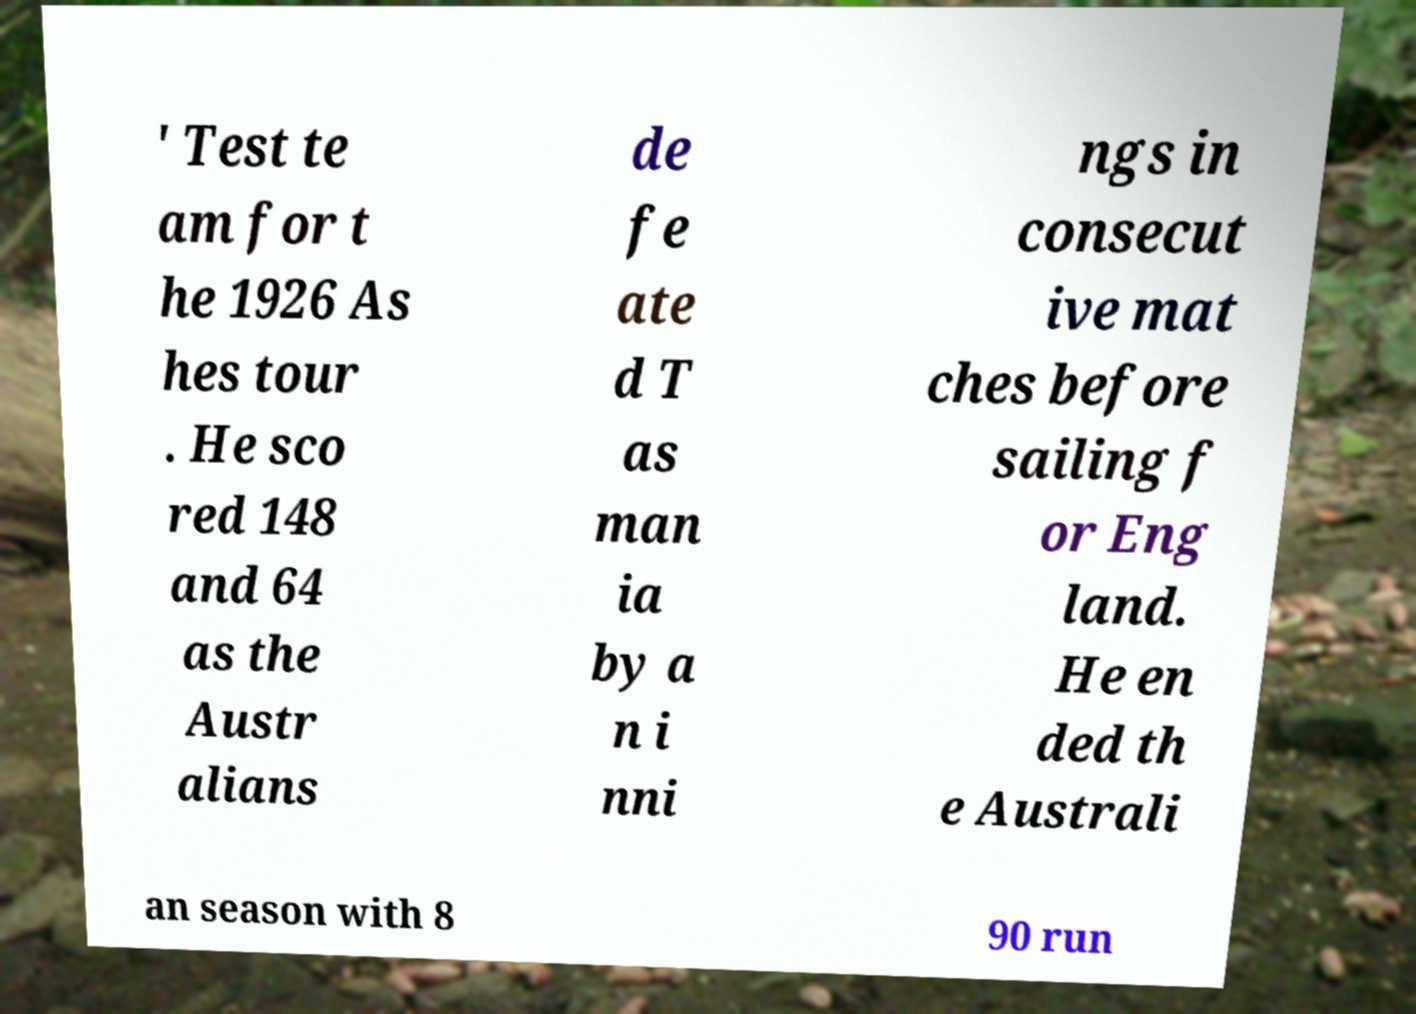There's text embedded in this image that I need extracted. Can you transcribe it verbatim? ' Test te am for t he 1926 As hes tour . He sco red 148 and 64 as the Austr alians de fe ate d T as man ia by a n i nni ngs in consecut ive mat ches before sailing f or Eng land. He en ded th e Australi an season with 8 90 run 